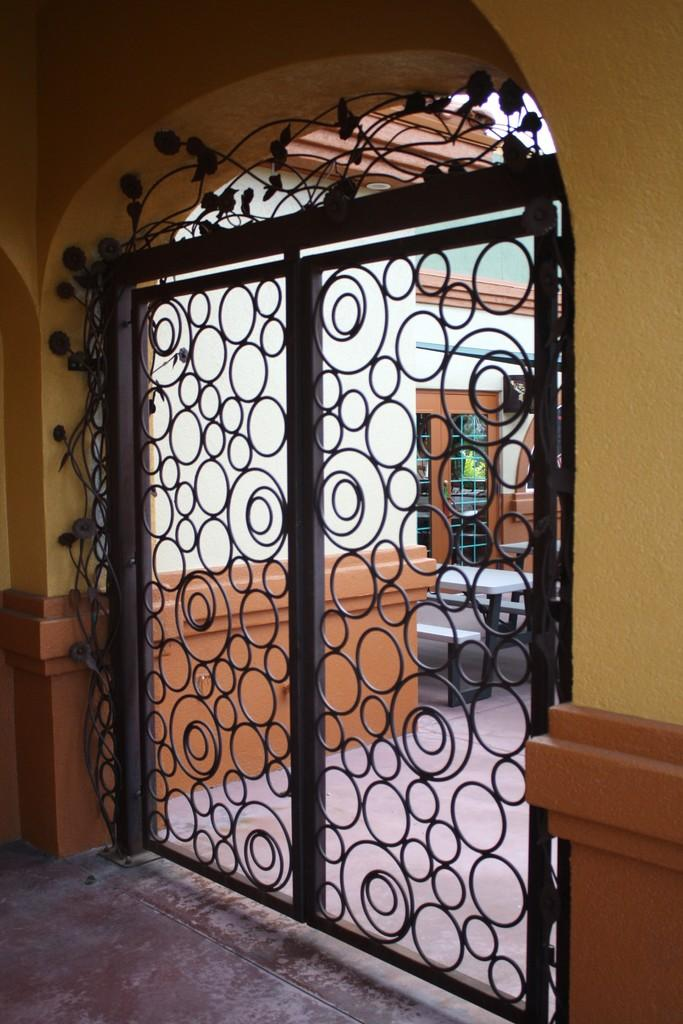What is there is a black gate in the center of the image, what is its purpose? The purpose of the black gate in the image is not explicitly stated, but it could be a barrier or entrance to a property or area. What other structures can be seen in the image? Walls are visible in the image, which may be part of a building or enclosure. What is at the bottom of the image? There is flooring at the bottom of the image, which could be a pathway, driveway, or other surface. How does the cave in the image contribute to the overall scene? There is no cave present in the image; it only features a black gate and walls. What type of stitch is used to create the pattern on the gate? The image does not provide enough detail to determine the type of stitch used on the gate, if any. 